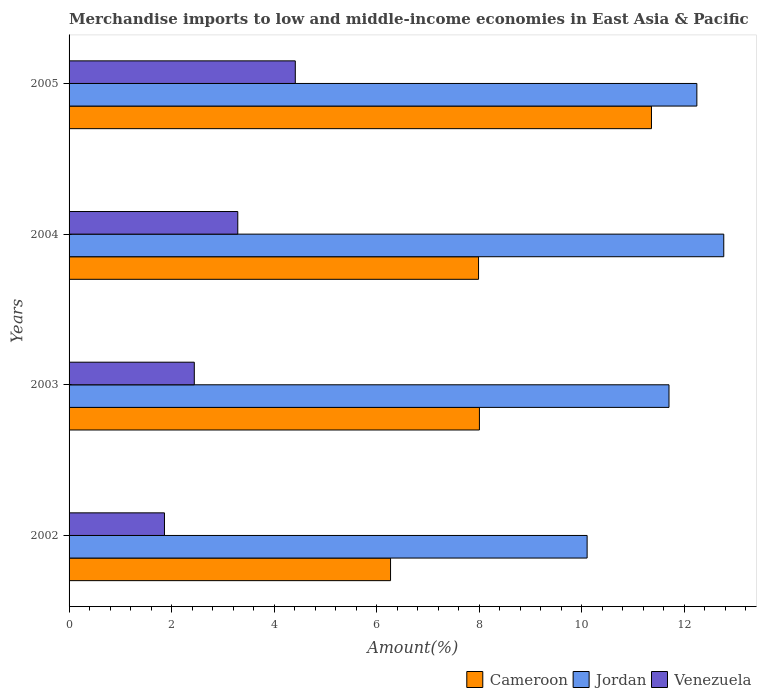How many groups of bars are there?
Provide a succinct answer. 4. Are the number of bars on each tick of the Y-axis equal?
Offer a terse response. Yes. How many bars are there on the 1st tick from the top?
Your answer should be compact. 3. In how many cases, is the number of bars for a given year not equal to the number of legend labels?
Your answer should be very brief. 0. What is the percentage of amount earned from merchandise imports in Jordan in 2002?
Your answer should be compact. 10.11. Across all years, what is the maximum percentage of amount earned from merchandise imports in Jordan?
Provide a succinct answer. 12.77. Across all years, what is the minimum percentage of amount earned from merchandise imports in Cameroon?
Offer a terse response. 6.27. In which year was the percentage of amount earned from merchandise imports in Venezuela maximum?
Offer a terse response. 2005. In which year was the percentage of amount earned from merchandise imports in Cameroon minimum?
Offer a terse response. 2002. What is the total percentage of amount earned from merchandise imports in Cameroon in the graph?
Offer a terse response. 33.63. What is the difference between the percentage of amount earned from merchandise imports in Venezuela in 2004 and that in 2005?
Keep it short and to the point. -1.12. What is the difference between the percentage of amount earned from merchandise imports in Cameroon in 2004 and the percentage of amount earned from merchandise imports in Venezuela in 2005?
Your answer should be very brief. 3.58. What is the average percentage of amount earned from merchandise imports in Cameroon per year?
Your answer should be very brief. 8.41. In the year 2005, what is the difference between the percentage of amount earned from merchandise imports in Venezuela and percentage of amount earned from merchandise imports in Cameroon?
Keep it short and to the point. -6.95. In how many years, is the percentage of amount earned from merchandise imports in Venezuela greater than 12.8 %?
Provide a short and direct response. 0. What is the ratio of the percentage of amount earned from merchandise imports in Cameroon in 2004 to that in 2005?
Provide a short and direct response. 0.7. What is the difference between the highest and the second highest percentage of amount earned from merchandise imports in Cameroon?
Ensure brevity in your answer.  3.36. What is the difference between the highest and the lowest percentage of amount earned from merchandise imports in Cameroon?
Your answer should be compact. 5.09. In how many years, is the percentage of amount earned from merchandise imports in Jordan greater than the average percentage of amount earned from merchandise imports in Jordan taken over all years?
Your response must be concise. 2. What does the 2nd bar from the top in 2002 represents?
Keep it short and to the point. Jordan. What does the 2nd bar from the bottom in 2005 represents?
Provide a short and direct response. Jordan. How many years are there in the graph?
Provide a short and direct response. 4. What is the difference between two consecutive major ticks on the X-axis?
Keep it short and to the point. 2. Are the values on the major ticks of X-axis written in scientific E-notation?
Your response must be concise. No. How many legend labels are there?
Ensure brevity in your answer.  3. How are the legend labels stacked?
Your answer should be compact. Horizontal. What is the title of the graph?
Offer a terse response. Merchandise imports to low and middle-income economies in East Asia & Pacific. What is the label or title of the X-axis?
Make the answer very short. Amount(%). What is the label or title of the Y-axis?
Offer a very short reply. Years. What is the Amount(%) in Cameroon in 2002?
Your answer should be very brief. 6.27. What is the Amount(%) of Jordan in 2002?
Give a very brief answer. 10.11. What is the Amount(%) in Venezuela in 2002?
Give a very brief answer. 1.86. What is the Amount(%) of Cameroon in 2003?
Your response must be concise. 8.01. What is the Amount(%) in Jordan in 2003?
Offer a terse response. 11.7. What is the Amount(%) of Venezuela in 2003?
Provide a short and direct response. 2.44. What is the Amount(%) of Cameroon in 2004?
Give a very brief answer. 7.99. What is the Amount(%) of Jordan in 2004?
Offer a very short reply. 12.77. What is the Amount(%) of Venezuela in 2004?
Make the answer very short. 3.29. What is the Amount(%) of Cameroon in 2005?
Your answer should be very brief. 11.36. What is the Amount(%) of Jordan in 2005?
Offer a very short reply. 12.25. What is the Amount(%) of Venezuela in 2005?
Your answer should be very brief. 4.41. Across all years, what is the maximum Amount(%) in Cameroon?
Provide a succinct answer. 11.36. Across all years, what is the maximum Amount(%) of Jordan?
Ensure brevity in your answer.  12.77. Across all years, what is the maximum Amount(%) of Venezuela?
Offer a terse response. 4.41. Across all years, what is the minimum Amount(%) in Cameroon?
Your answer should be very brief. 6.27. Across all years, what is the minimum Amount(%) of Jordan?
Provide a short and direct response. 10.11. Across all years, what is the minimum Amount(%) of Venezuela?
Ensure brevity in your answer.  1.86. What is the total Amount(%) of Cameroon in the graph?
Your response must be concise. 33.63. What is the total Amount(%) of Jordan in the graph?
Your answer should be compact. 46.83. What is the total Amount(%) in Venezuela in the graph?
Offer a very short reply. 12.01. What is the difference between the Amount(%) in Cameroon in 2002 and that in 2003?
Provide a short and direct response. -1.73. What is the difference between the Amount(%) in Jordan in 2002 and that in 2003?
Make the answer very short. -1.6. What is the difference between the Amount(%) of Venezuela in 2002 and that in 2003?
Offer a terse response. -0.58. What is the difference between the Amount(%) of Cameroon in 2002 and that in 2004?
Your answer should be very brief. -1.72. What is the difference between the Amount(%) of Jordan in 2002 and that in 2004?
Ensure brevity in your answer.  -2.67. What is the difference between the Amount(%) of Venezuela in 2002 and that in 2004?
Provide a succinct answer. -1.43. What is the difference between the Amount(%) in Cameroon in 2002 and that in 2005?
Provide a short and direct response. -5.09. What is the difference between the Amount(%) of Jordan in 2002 and that in 2005?
Make the answer very short. -2.14. What is the difference between the Amount(%) of Venezuela in 2002 and that in 2005?
Offer a very short reply. -2.55. What is the difference between the Amount(%) in Cameroon in 2003 and that in 2004?
Make the answer very short. 0.02. What is the difference between the Amount(%) of Jordan in 2003 and that in 2004?
Your answer should be very brief. -1.07. What is the difference between the Amount(%) of Venezuela in 2003 and that in 2004?
Ensure brevity in your answer.  -0.85. What is the difference between the Amount(%) in Cameroon in 2003 and that in 2005?
Give a very brief answer. -3.36. What is the difference between the Amount(%) in Jordan in 2003 and that in 2005?
Keep it short and to the point. -0.54. What is the difference between the Amount(%) of Venezuela in 2003 and that in 2005?
Provide a short and direct response. -1.97. What is the difference between the Amount(%) in Cameroon in 2004 and that in 2005?
Ensure brevity in your answer.  -3.37. What is the difference between the Amount(%) in Jordan in 2004 and that in 2005?
Give a very brief answer. 0.52. What is the difference between the Amount(%) in Venezuela in 2004 and that in 2005?
Give a very brief answer. -1.12. What is the difference between the Amount(%) in Cameroon in 2002 and the Amount(%) in Jordan in 2003?
Provide a succinct answer. -5.43. What is the difference between the Amount(%) of Cameroon in 2002 and the Amount(%) of Venezuela in 2003?
Make the answer very short. 3.83. What is the difference between the Amount(%) of Jordan in 2002 and the Amount(%) of Venezuela in 2003?
Your answer should be very brief. 7.66. What is the difference between the Amount(%) of Cameroon in 2002 and the Amount(%) of Jordan in 2004?
Your answer should be very brief. -6.5. What is the difference between the Amount(%) in Cameroon in 2002 and the Amount(%) in Venezuela in 2004?
Your answer should be compact. 2.98. What is the difference between the Amount(%) in Jordan in 2002 and the Amount(%) in Venezuela in 2004?
Your answer should be compact. 6.82. What is the difference between the Amount(%) in Cameroon in 2002 and the Amount(%) in Jordan in 2005?
Your answer should be compact. -5.98. What is the difference between the Amount(%) in Cameroon in 2002 and the Amount(%) in Venezuela in 2005?
Your answer should be compact. 1.86. What is the difference between the Amount(%) in Jordan in 2002 and the Amount(%) in Venezuela in 2005?
Your answer should be very brief. 5.69. What is the difference between the Amount(%) of Cameroon in 2003 and the Amount(%) of Jordan in 2004?
Your response must be concise. -4.77. What is the difference between the Amount(%) of Cameroon in 2003 and the Amount(%) of Venezuela in 2004?
Ensure brevity in your answer.  4.71. What is the difference between the Amount(%) in Jordan in 2003 and the Amount(%) in Venezuela in 2004?
Give a very brief answer. 8.41. What is the difference between the Amount(%) in Cameroon in 2003 and the Amount(%) in Jordan in 2005?
Offer a terse response. -4.24. What is the difference between the Amount(%) in Cameroon in 2003 and the Amount(%) in Venezuela in 2005?
Ensure brevity in your answer.  3.59. What is the difference between the Amount(%) of Jordan in 2003 and the Amount(%) of Venezuela in 2005?
Your answer should be compact. 7.29. What is the difference between the Amount(%) of Cameroon in 2004 and the Amount(%) of Jordan in 2005?
Your response must be concise. -4.26. What is the difference between the Amount(%) of Cameroon in 2004 and the Amount(%) of Venezuela in 2005?
Your response must be concise. 3.58. What is the difference between the Amount(%) of Jordan in 2004 and the Amount(%) of Venezuela in 2005?
Your response must be concise. 8.36. What is the average Amount(%) of Cameroon per year?
Your answer should be compact. 8.41. What is the average Amount(%) of Jordan per year?
Keep it short and to the point. 11.71. What is the average Amount(%) in Venezuela per year?
Give a very brief answer. 3. In the year 2002, what is the difference between the Amount(%) in Cameroon and Amount(%) in Jordan?
Offer a terse response. -3.84. In the year 2002, what is the difference between the Amount(%) of Cameroon and Amount(%) of Venezuela?
Make the answer very short. 4.41. In the year 2002, what is the difference between the Amount(%) in Jordan and Amount(%) in Venezuela?
Make the answer very short. 8.25. In the year 2003, what is the difference between the Amount(%) in Cameroon and Amount(%) in Jordan?
Give a very brief answer. -3.7. In the year 2003, what is the difference between the Amount(%) of Cameroon and Amount(%) of Venezuela?
Your answer should be very brief. 5.56. In the year 2003, what is the difference between the Amount(%) of Jordan and Amount(%) of Venezuela?
Offer a very short reply. 9.26. In the year 2004, what is the difference between the Amount(%) in Cameroon and Amount(%) in Jordan?
Provide a succinct answer. -4.78. In the year 2004, what is the difference between the Amount(%) of Cameroon and Amount(%) of Venezuela?
Provide a succinct answer. 4.7. In the year 2004, what is the difference between the Amount(%) in Jordan and Amount(%) in Venezuela?
Your answer should be compact. 9.48. In the year 2005, what is the difference between the Amount(%) in Cameroon and Amount(%) in Jordan?
Make the answer very short. -0.89. In the year 2005, what is the difference between the Amount(%) in Cameroon and Amount(%) in Venezuela?
Give a very brief answer. 6.95. In the year 2005, what is the difference between the Amount(%) in Jordan and Amount(%) in Venezuela?
Give a very brief answer. 7.83. What is the ratio of the Amount(%) in Cameroon in 2002 to that in 2003?
Your response must be concise. 0.78. What is the ratio of the Amount(%) of Jordan in 2002 to that in 2003?
Your answer should be very brief. 0.86. What is the ratio of the Amount(%) in Venezuela in 2002 to that in 2003?
Provide a short and direct response. 0.76. What is the ratio of the Amount(%) of Cameroon in 2002 to that in 2004?
Provide a succinct answer. 0.79. What is the ratio of the Amount(%) of Jordan in 2002 to that in 2004?
Give a very brief answer. 0.79. What is the ratio of the Amount(%) of Venezuela in 2002 to that in 2004?
Provide a succinct answer. 0.57. What is the ratio of the Amount(%) in Cameroon in 2002 to that in 2005?
Your answer should be very brief. 0.55. What is the ratio of the Amount(%) of Jordan in 2002 to that in 2005?
Give a very brief answer. 0.83. What is the ratio of the Amount(%) of Venezuela in 2002 to that in 2005?
Keep it short and to the point. 0.42. What is the ratio of the Amount(%) in Cameroon in 2003 to that in 2004?
Offer a terse response. 1. What is the ratio of the Amount(%) in Jordan in 2003 to that in 2004?
Offer a terse response. 0.92. What is the ratio of the Amount(%) of Venezuela in 2003 to that in 2004?
Ensure brevity in your answer.  0.74. What is the ratio of the Amount(%) of Cameroon in 2003 to that in 2005?
Offer a terse response. 0.7. What is the ratio of the Amount(%) in Jordan in 2003 to that in 2005?
Provide a succinct answer. 0.96. What is the ratio of the Amount(%) in Venezuela in 2003 to that in 2005?
Make the answer very short. 0.55. What is the ratio of the Amount(%) of Cameroon in 2004 to that in 2005?
Offer a very short reply. 0.7. What is the ratio of the Amount(%) in Jordan in 2004 to that in 2005?
Give a very brief answer. 1.04. What is the ratio of the Amount(%) of Venezuela in 2004 to that in 2005?
Your response must be concise. 0.75. What is the difference between the highest and the second highest Amount(%) of Cameroon?
Offer a terse response. 3.36. What is the difference between the highest and the second highest Amount(%) in Jordan?
Your response must be concise. 0.52. What is the difference between the highest and the second highest Amount(%) of Venezuela?
Offer a terse response. 1.12. What is the difference between the highest and the lowest Amount(%) of Cameroon?
Provide a short and direct response. 5.09. What is the difference between the highest and the lowest Amount(%) of Jordan?
Make the answer very short. 2.67. What is the difference between the highest and the lowest Amount(%) of Venezuela?
Your answer should be compact. 2.55. 